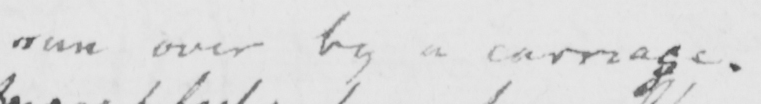What is written in this line of handwriting? run over by a carriage 